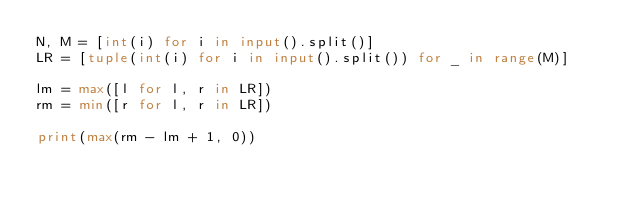<code> <loc_0><loc_0><loc_500><loc_500><_Python_>N, M = [int(i) for i in input().split()]
LR = [tuple(int(i) for i in input().split()) for _ in range(M)]

lm = max([l for l, r in LR])
rm = min([r for l, r in LR])

print(max(rm - lm + 1, 0))</code> 